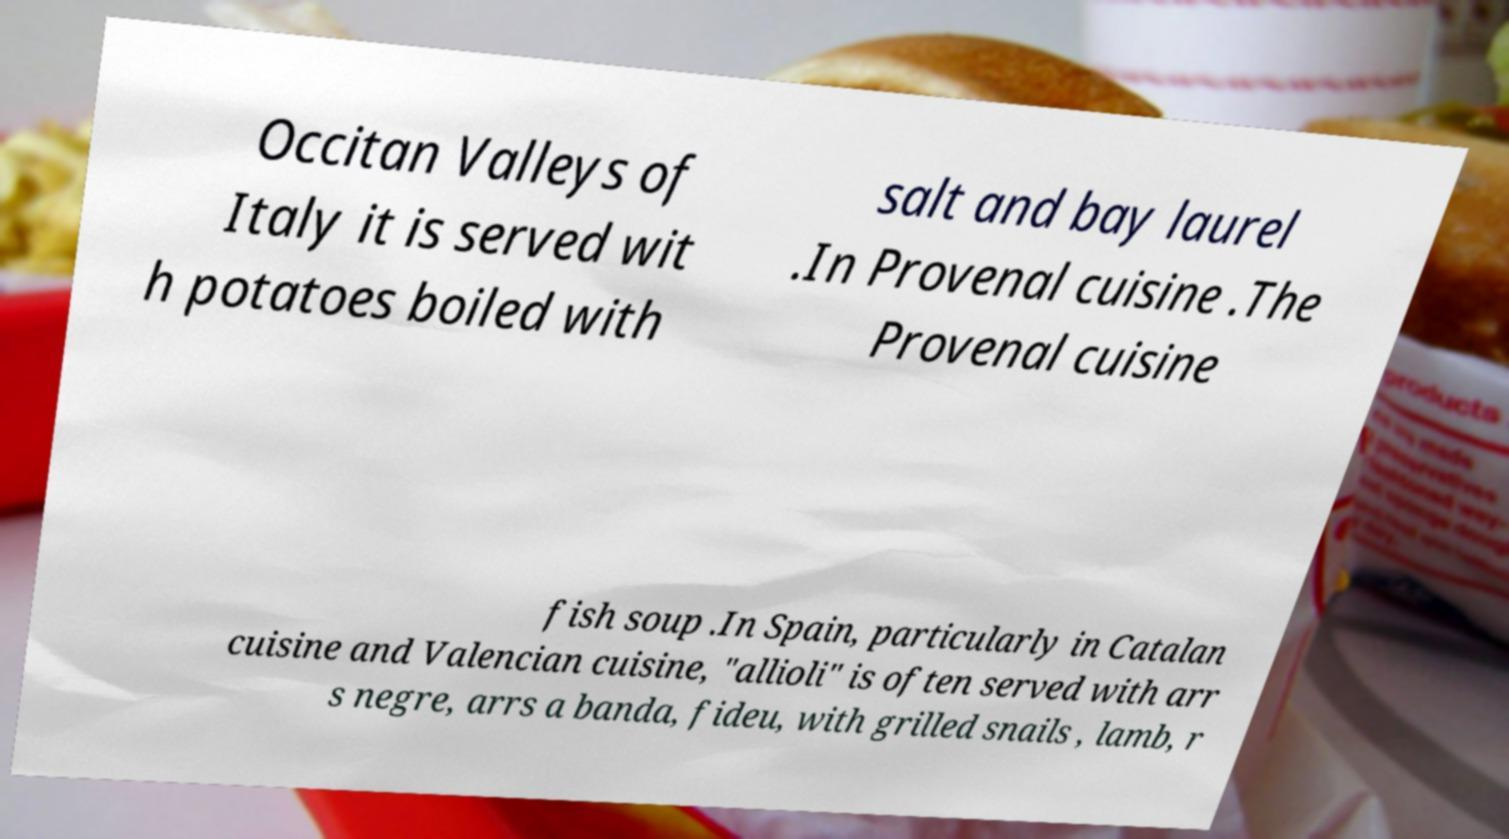What messages or text are displayed in this image? I need them in a readable, typed format. Occitan Valleys of Italy it is served wit h potatoes boiled with salt and bay laurel .In Provenal cuisine .The Provenal cuisine fish soup .In Spain, particularly in Catalan cuisine and Valencian cuisine, "allioli" is often served with arr s negre, arrs a banda, fideu, with grilled snails , lamb, r 